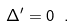<formula> <loc_0><loc_0><loc_500><loc_500>\Delta ^ { \prime } = 0 \ .</formula> 